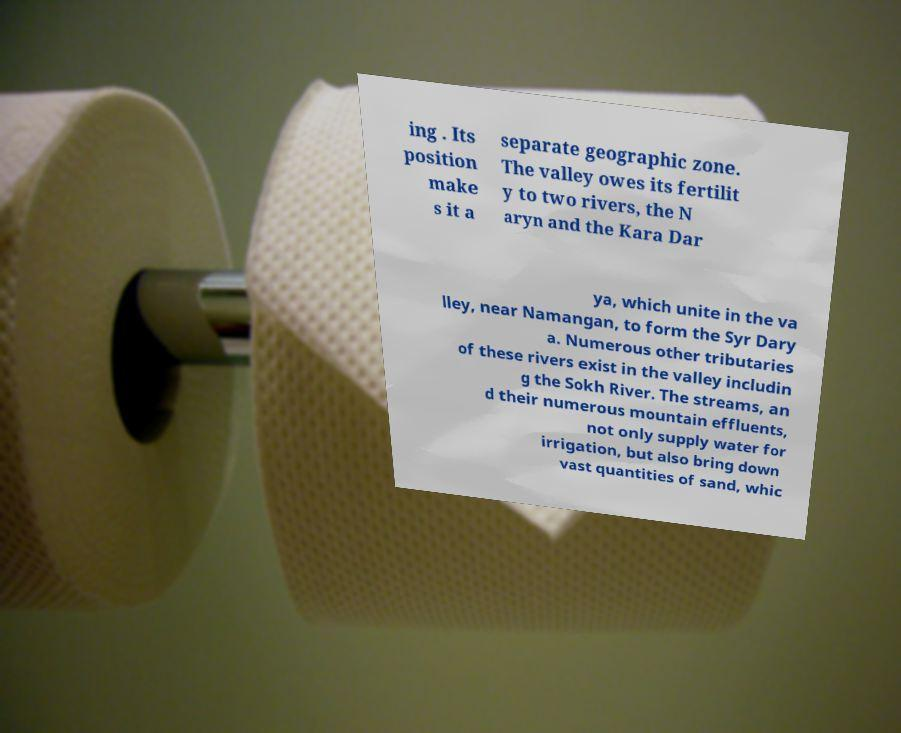Could you assist in decoding the text presented in this image and type it out clearly? ing . Its position make s it a separate geographic zone. The valley owes its fertilit y to two rivers, the N aryn and the Kara Dar ya, which unite in the va lley, near Namangan, to form the Syr Dary a. Numerous other tributaries of these rivers exist in the valley includin g the Sokh River. The streams, an d their numerous mountain effluents, not only supply water for irrigation, but also bring down vast quantities of sand, whic 